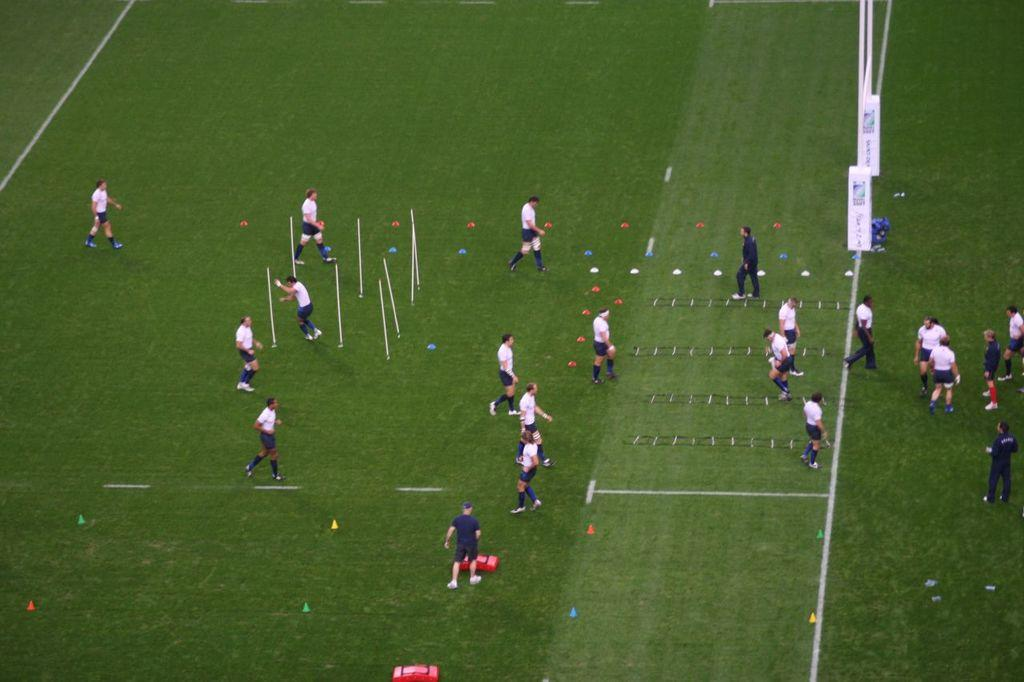What is the main subject of the image? The main subject of the image is a group of people. What are the people doing in the image? The people are standing in the image. What can be observed about the people's appearance in the image? The people are wearing clothes. What type of wool is being spun by the tree in the image? There is no tree or wool present in the image; it features a group of people standing and wearing clothes. 